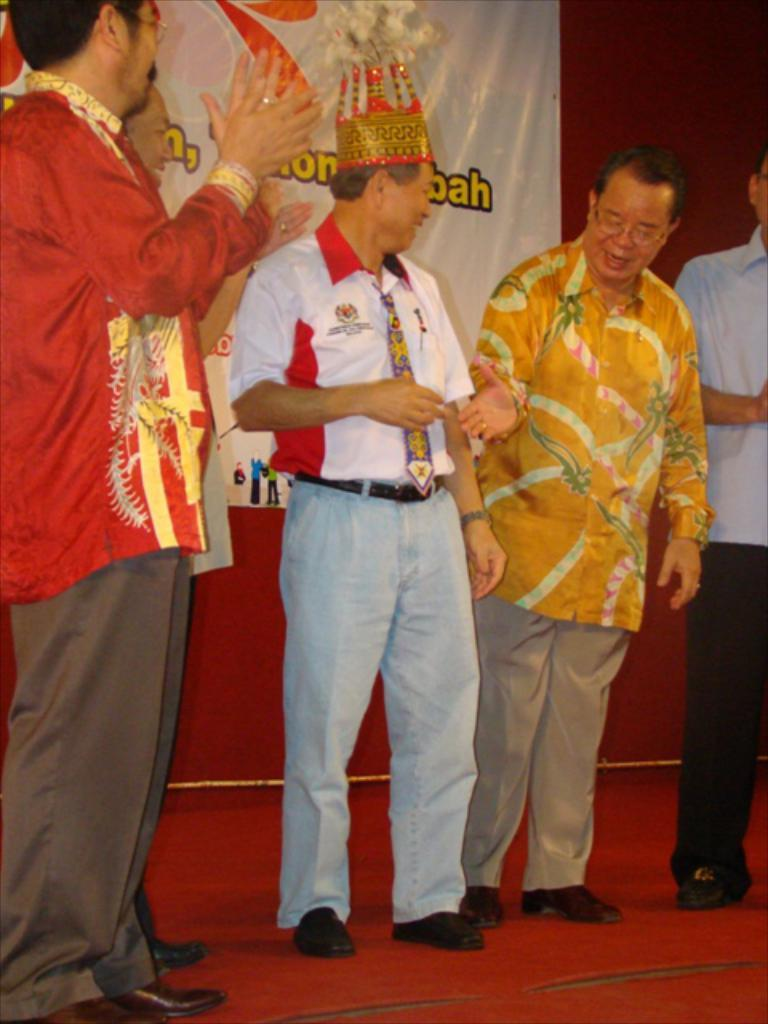How many people are in the group in the image? There is a group of people in the image. What can be observed about the attire of the people in the group? The people are wearing different color dresses. Can you identify any specific accessory worn by one of the people in the group? One person in the group is wearing a crown. What is present in the background of the image? There is a banner in the background of the image. What is the color of the surface on which the banner is placed? The banner is on a red color surface. What type of mountain can be seen in the background of the image? There is no mountain visible in the background of the image. How does the comfort level of the people in the group affect their appearance in the image? The comfort level of the people in the group cannot be determined from the image, as it only shows their attire and the presence of a crown on one person. 